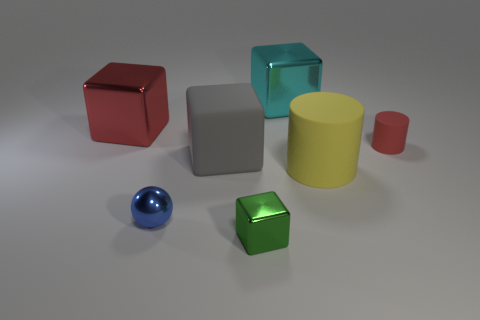What number of cyan shiny things have the same size as the green metallic thing?
Give a very brief answer. 0. How many large objects are to the left of the matte thing in front of the big block in front of the tiny rubber cylinder?
Ensure brevity in your answer.  3. Are there the same number of large metallic things that are to the left of the blue metal object and tiny red rubber things behind the large gray rubber thing?
Provide a short and direct response. Yes. How many green shiny objects are the same shape as the large red thing?
Provide a succinct answer. 1. Are there any yellow cylinders made of the same material as the tiny green block?
Make the answer very short. No. How many big green cylinders are there?
Offer a very short reply. 0. What number of balls are yellow rubber things or large red things?
Your response must be concise. 0. What color is the shiny block that is the same size as the blue object?
Provide a short and direct response. Green. What number of objects are both behind the small red thing and in front of the tiny matte cylinder?
Provide a succinct answer. 0. What material is the tiny green cube?
Ensure brevity in your answer.  Metal. 